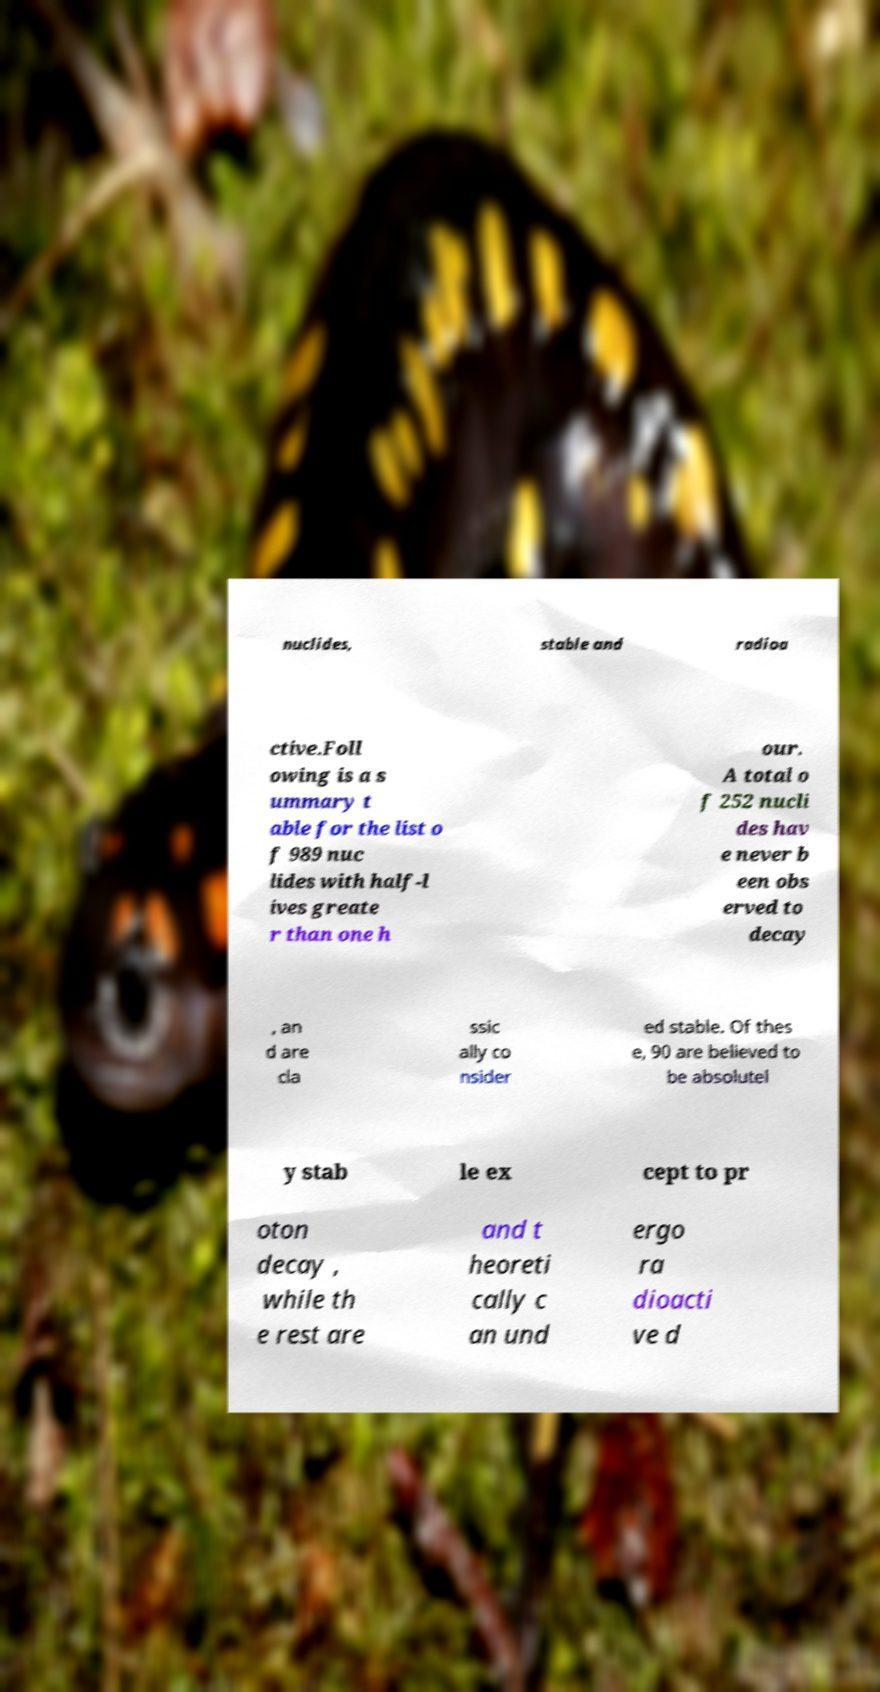Can you accurately transcribe the text from the provided image for me? nuclides, stable and radioa ctive.Foll owing is a s ummary t able for the list o f 989 nuc lides with half-l ives greate r than one h our. A total o f 252 nucli des hav e never b een obs erved to decay , an d are cla ssic ally co nsider ed stable. Of thes e, 90 are believed to be absolutel y stab le ex cept to pr oton decay , while th e rest are and t heoreti cally c an und ergo ra dioacti ve d 